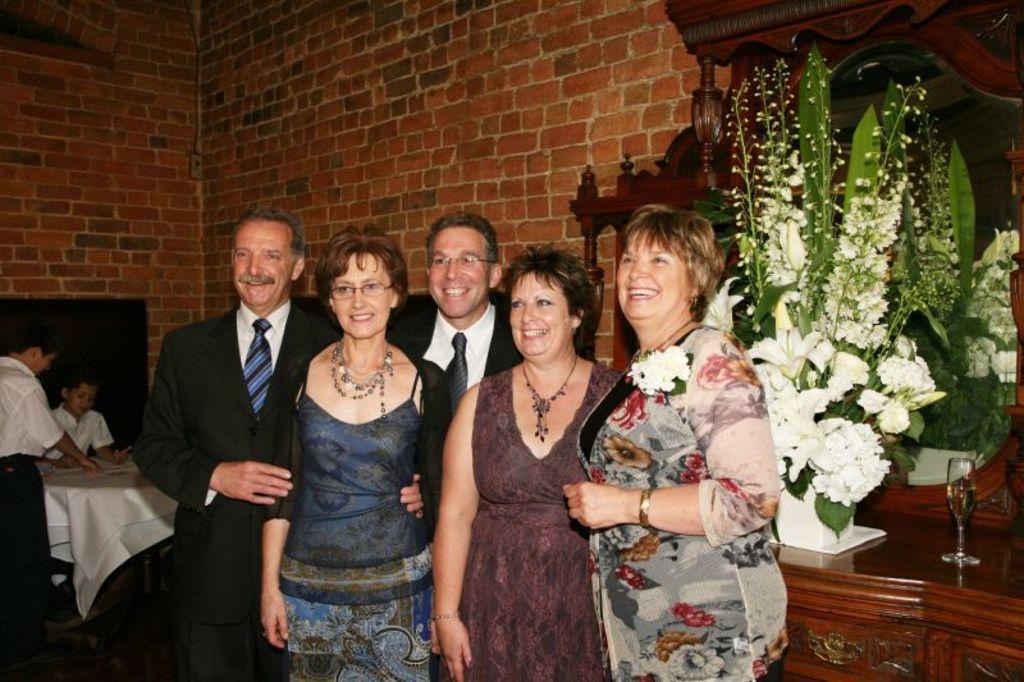How would you summarize this image in a sentence or two? In this image we can see few persons are standing and on the right side there is a flower vase and a glass with liquid in it on a table and behind them there is a mirror. In the background there are few persons at the table and we can see the wall. 